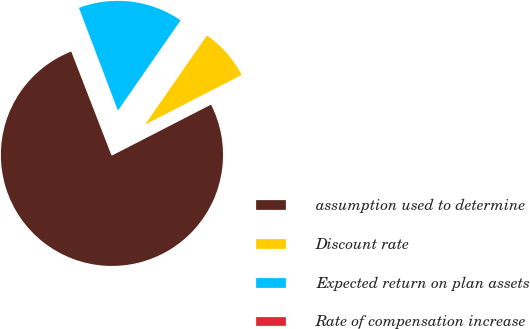Convert chart to OTSL. <chart><loc_0><loc_0><loc_500><loc_500><pie_chart><fcel>assumption used to determine<fcel>Discount rate<fcel>Expected return on plan assets<fcel>Rate of compensation increase<nl><fcel>76.67%<fcel>7.78%<fcel>15.43%<fcel>0.12%<nl></chart> 